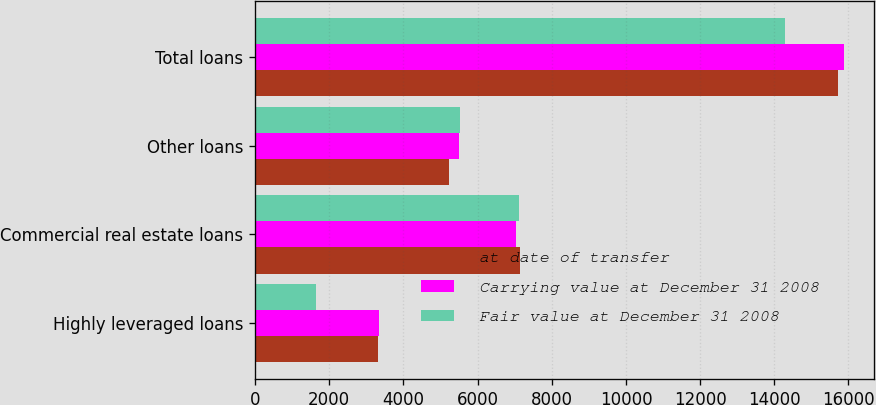Convert chart. <chart><loc_0><loc_0><loc_500><loc_500><stacked_bar_chart><ecel><fcel>Highly leveraged loans<fcel>Commercial real estate loans<fcel>Other loans<fcel>Total loans<nl><fcel>at date of transfer<fcel>3318<fcel>7150<fcel>5241<fcel>15709<nl><fcel>Carrying value at December 31 2008<fcel>3350<fcel>7049<fcel>5492<fcel>15891<nl><fcel>Fair value at December 31 2008<fcel>1650<fcel>7110<fcel>5523<fcel>14283<nl></chart> 